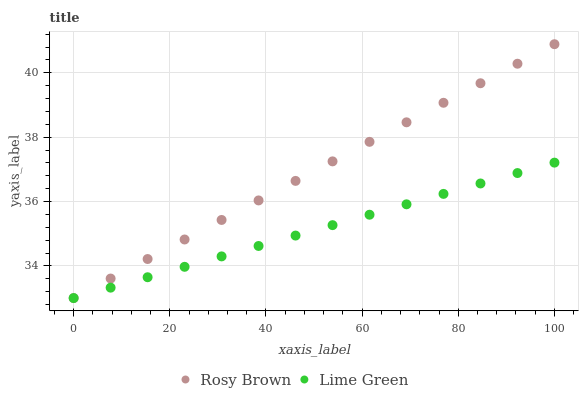Does Lime Green have the minimum area under the curve?
Answer yes or no. Yes. Does Rosy Brown have the maximum area under the curve?
Answer yes or no. Yes. Does Lime Green have the maximum area under the curve?
Answer yes or no. No. Is Lime Green the smoothest?
Answer yes or no. Yes. Is Rosy Brown the roughest?
Answer yes or no. Yes. Is Lime Green the roughest?
Answer yes or no. No. Does Rosy Brown have the lowest value?
Answer yes or no. Yes. Does Rosy Brown have the highest value?
Answer yes or no. Yes. Does Lime Green have the highest value?
Answer yes or no. No. Does Lime Green intersect Rosy Brown?
Answer yes or no. Yes. Is Lime Green less than Rosy Brown?
Answer yes or no. No. Is Lime Green greater than Rosy Brown?
Answer yes or no. No. 